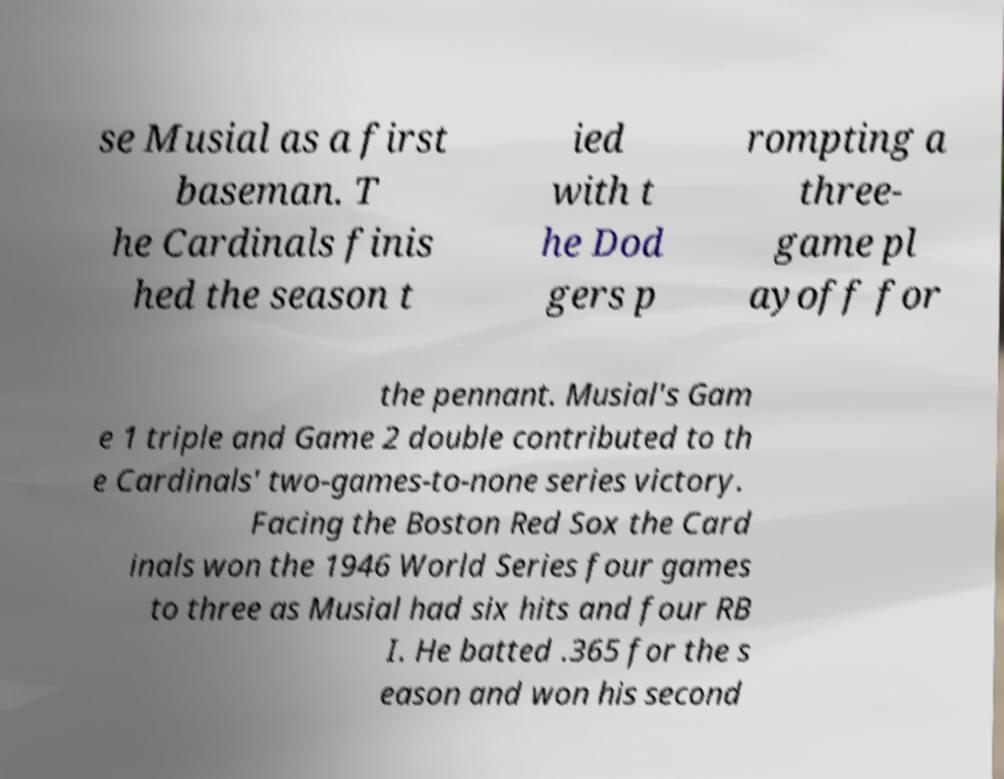I need the written content from this picture converted into text. Can you do that? se Musial as a first baseman. T he Cardinals finis hed the season t ied with t he Dod gers p rompting a three- game pl ayoff for the pennant. Musial's Gam e 1 triple and Game 2 double contributed to th e Cardinals' two-games-to-none series victory. Facing the Boston Red Sox the Card inals won the 1946 World Series four games to three as Musial had six hits and four RB I. He batted .365 for the s eason and won his second 